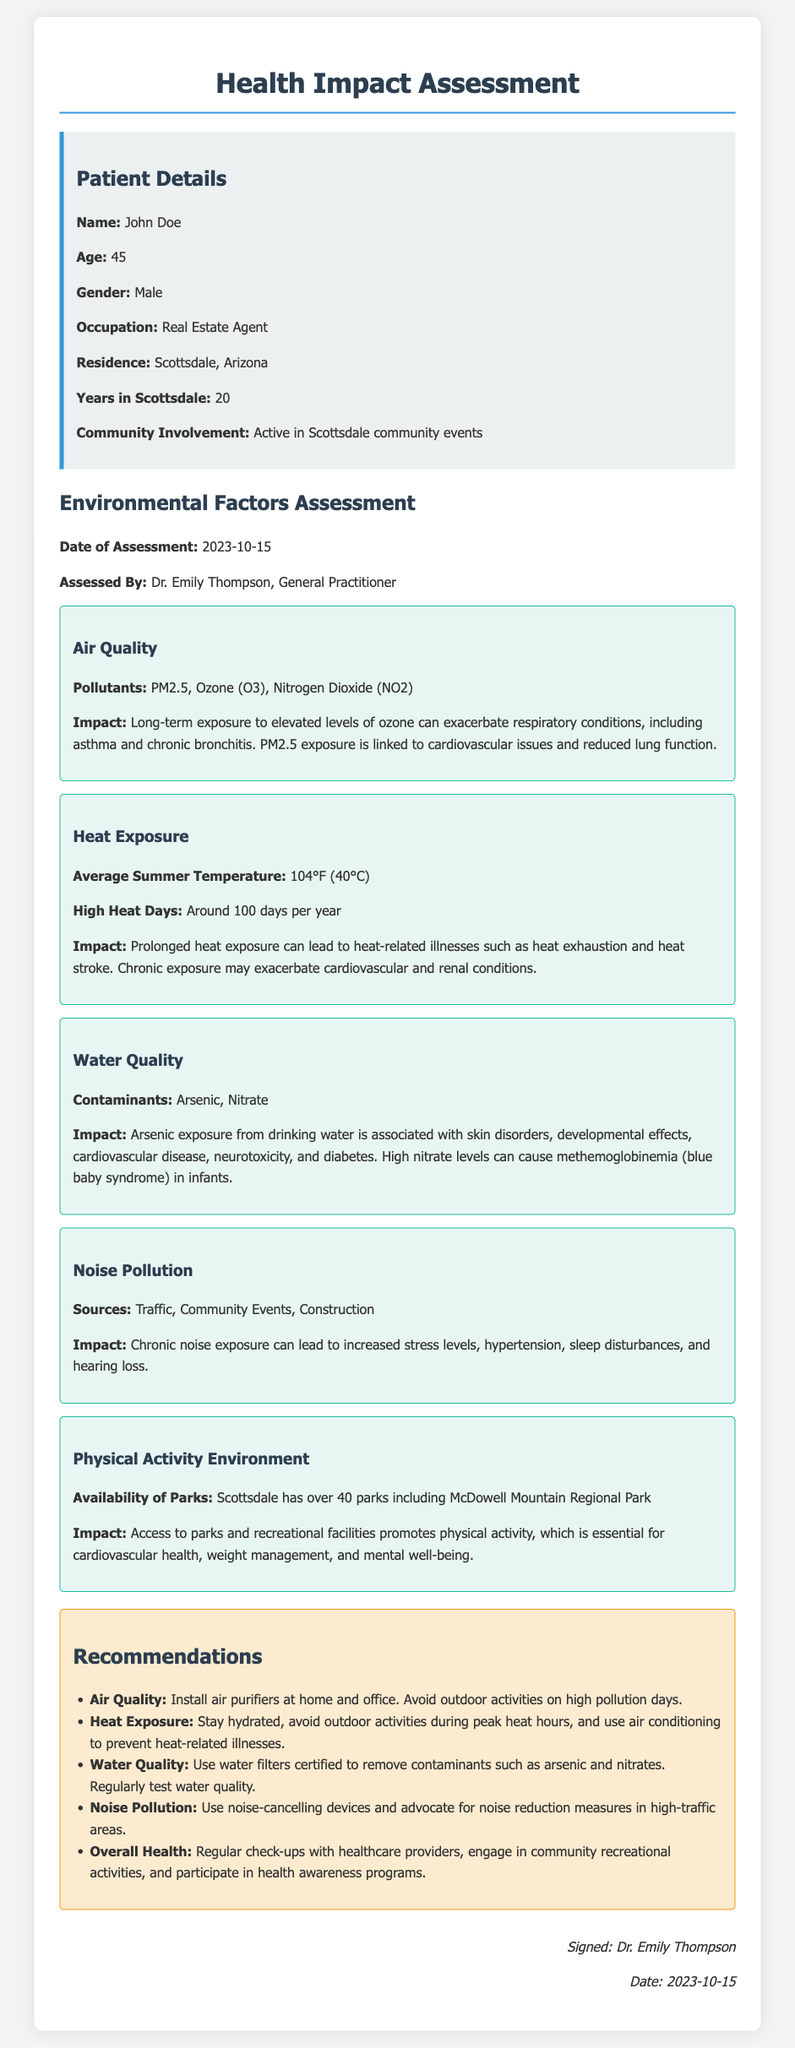What is the age of the patient? The age of the patient, John Doe, is provided in the document.
Answer: 45 Who assessed the environmental factors? The document states that the assessment was conducted by Dr. Emily Thompson.
Answer: Dr. Emily Thompson What pollutant is linked to cardiovascular issues? The document lists pollutants and their impacts, specifying PM2.5 as related to cardiovascular issues.
Answer: PM2.5 How many parks are available in Scottsdale? The document mentions that Scottsdale has over 40 parks.
Answer: Over 40 What average summer temperature is indicated? The assessment specifies the average summer temperature is 104°F (40°C).
Answer: 104°F (40°C) What is one recommendation for noise pollution? The recommendations section includes a specific advice relating to noise pollution, suggesting the use of noise-cancelling devices.
Answer: Use noise-cancelling devices What is a health impact of long-term ozone exposure? The document describes the impact of ozone, noting it can exacerbate respiratory conditions.
Answer: Exacerbate respiratory conditions When was the assessment conducted? The document provides a date for the assessment, which is significant for reference.
Answer: 2023-10-15 